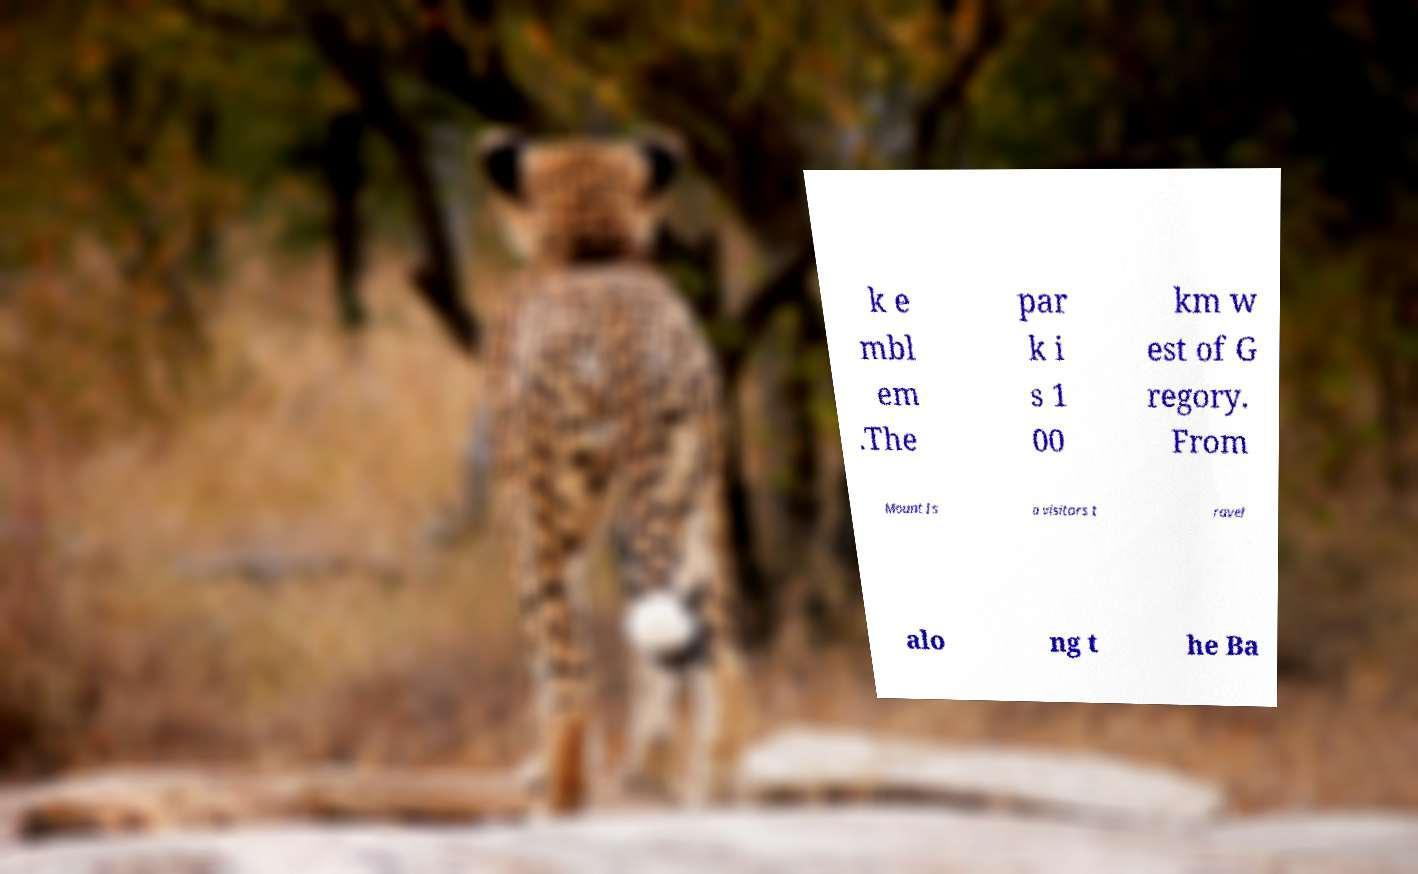Can you accurately transcribe the text from the provided image for me? k e mbl em .The par k i s 1 00 km w est of G regory. From Mount Is a visitors t ravel alo ng t he Ba 